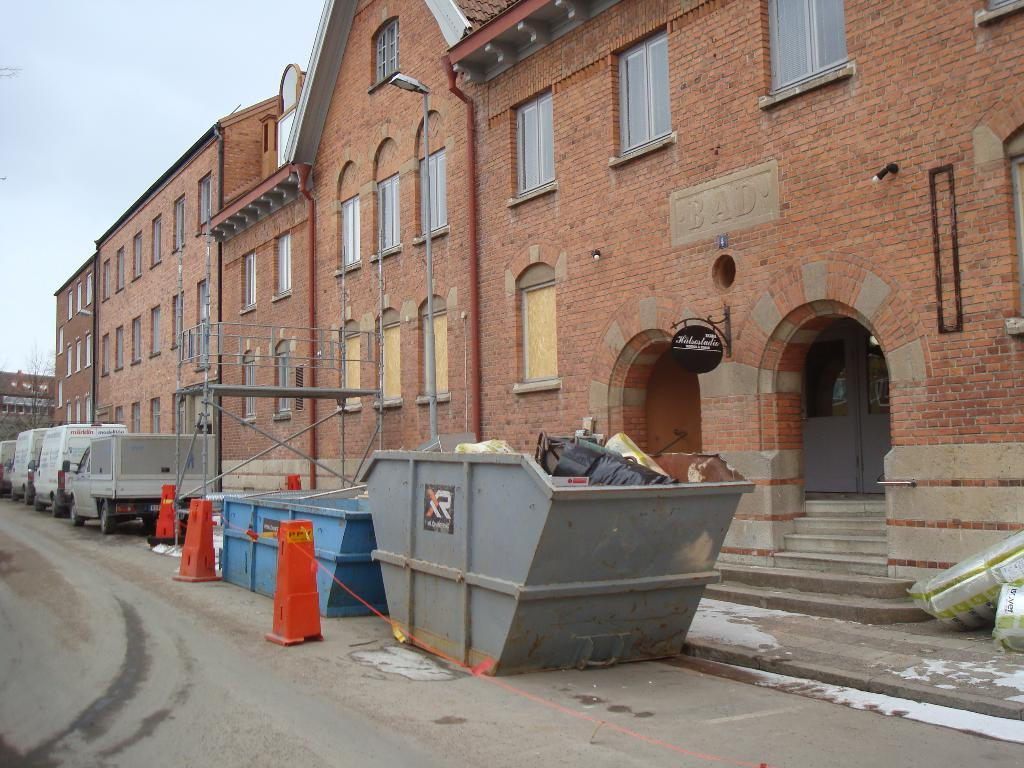What is the main structure in the image? There is a huge building in the image. What is located in front of the building? There is a big dustbin in front of the building. What else can be seen near the dustbin? There are vehicles visible beside the dustbin. What type of rake is being used to clean the vehicles in the image? There is no rake present in the image, and the vehicles are not being cleaned. 